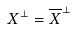<formula> <loc_0><loc_0><loc_500><loc_500>X ^ { \perp } = \overline { X } ^ { \perp }</formula> 